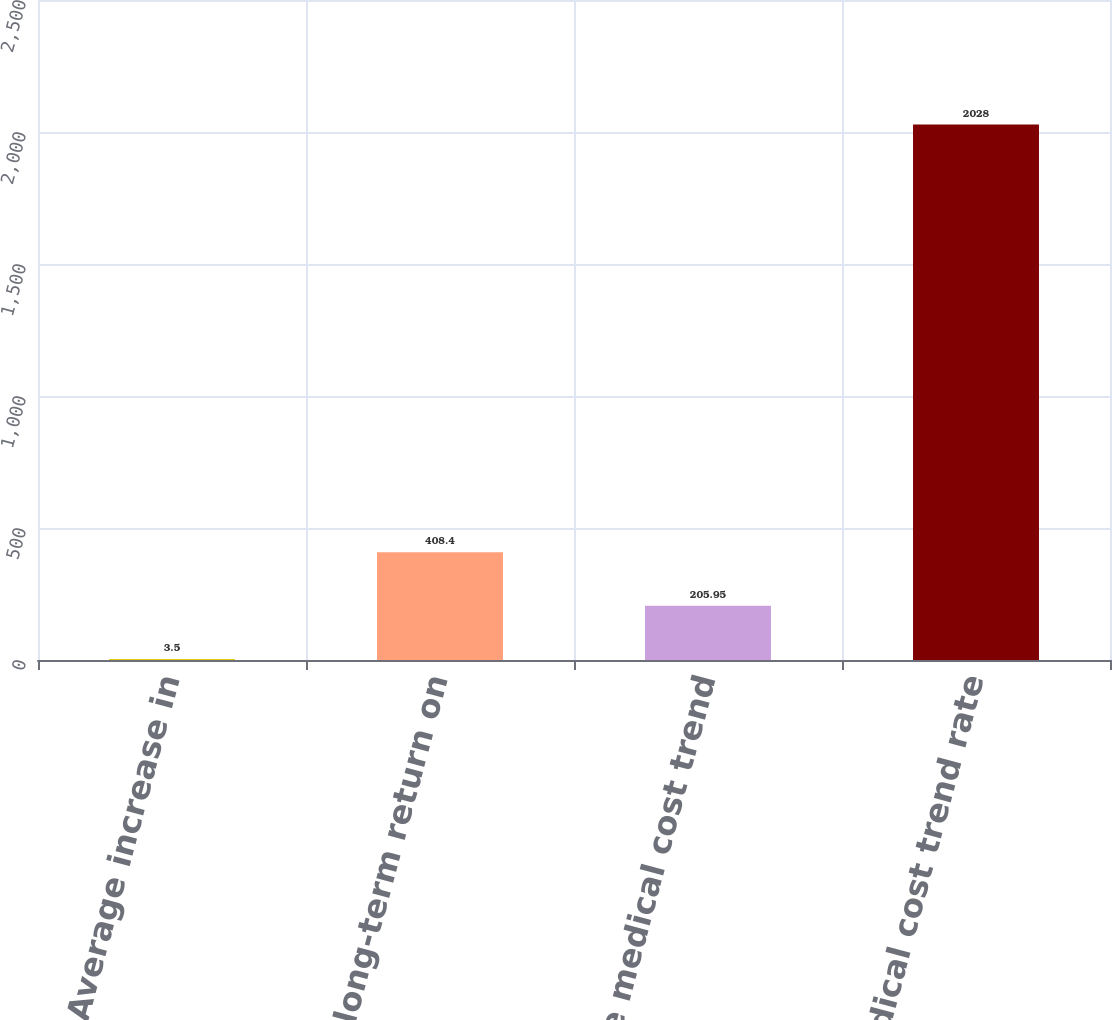Convert chart to OTSL. <chart><loc_0><loc_0><loc_500><loc_500><bar_chart><fcel>Average increase in<fcel>Expected long-term return on<fcel>Ultimate medical cost trend<fcel>Medical cost trend rate<nl><fcel>3.5<fcel>408.4<fcel>205.95<fcel>2028<nl></chart> 